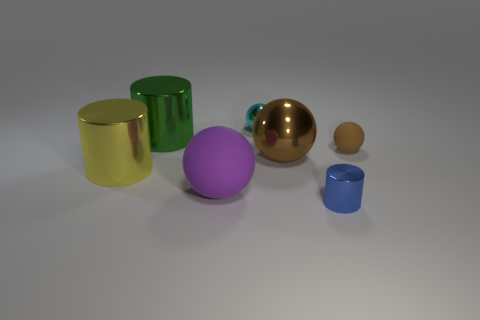What is the size of the object that is made of the same material as the small brown sphere?
Provide a succinct answer. Large. The small rubber sphere has what color?
Ensure brevity in your answer.  Brown. What number of large cylinders are the same color as the tiny shiny sphere?
Offer a terse response. 0. What material is the yellow cylinder that is the same size as the purple matte sphere?
Ensure brevity in your answer.  Metal. Are there any tiny blue things behind the shiny cylinder in front of the yellow cylinder?
Your answer should be very brief. No. What number of other things are the same color as the tiny cylinder?
Your answer should be very brief. 0. What is the size of the green cylinder?
Keep it short and to the point. Large. Are any small brown matte balls visible?
Provide a succinct answer. Yes. Are there more yellow metallic cylinders that are to the right of the cyan metallic thing than large yellow cylinders that are in front of the purple rubber object?
Offer a very short reply. No. There is a cylinder that is in front of the big brown ball and on the left side of the tiny cylinder; what is its material?
Your response must be concise. Metal. 